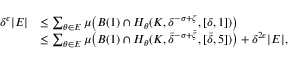<formula> <loc_0><loc_0><loc_500><loc_500>\begin{array} { r l } { \delta ^ { \epsilon } | E | } & { \leq \sum _ { \theta \in E } \mu \left ( B ( 1 ) \cap H _ { \theta } ( K , \delta ^ { - \sigma + \zeta } , [ \delta , 1 ] ) \right ) } \\ & { \leq \sum _ { \theta \in E } \mu \left ( B ( 1 ) \cap H _ { \theta } ( K , \bar { \delta } ^ { - \sigma + \bar { \zeta } } , [ \bar { \delta } , 5 ] ) \right ) + \delta ^ { 2 \epsilon } | E | , } \end{array}</formula> 